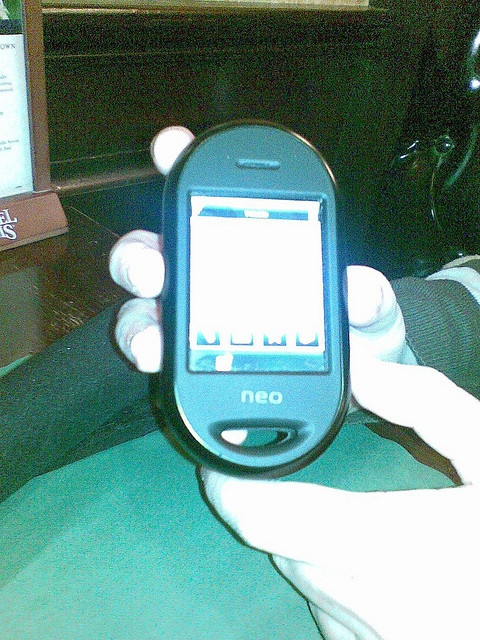Describe the objects in this image and their specific colors. I can see people in beige, white, lightblue, and teal tones and cell phone in beige, white, lightblue, and teal tones in this image. 